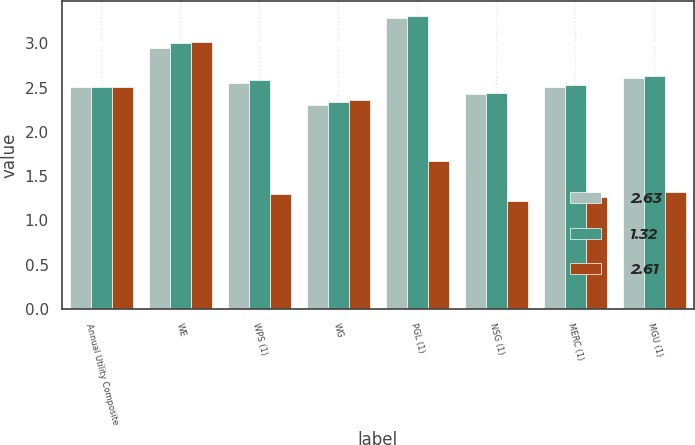<chart> <loc_0><loc_0><loc_500><loc_500><stacked_bar_chart><ecel><fcel>Annual Utility Composite<fcel>WE<fcel>WPS (1)<fcel>WG<fcel>PGL (1)<fcel>NSG (1)<fcel>MERC (1)<fcel>MGU (1)<nl><fcel>2.63<fcel>2.51<fcel>2.95<fcel>2.55<fcel>2.3<fcel>3.29<fcel>2.43<fcel>2.51<fcel>2.61<nl><fcel>1.32<fcel>2.51<fcel>3<fcel>2.58<fcel>2.34<fcel>3.31<fcel>2.44<fcel>2.53<fcel>2.63<nl><fcel>2.61<fcel>2.51<fcel>3.01<fcel>1.3<fcel>2.36<fcel>1.67<fcel>1.22<fcel>1.26<fcel>1.32<nl></chart> 